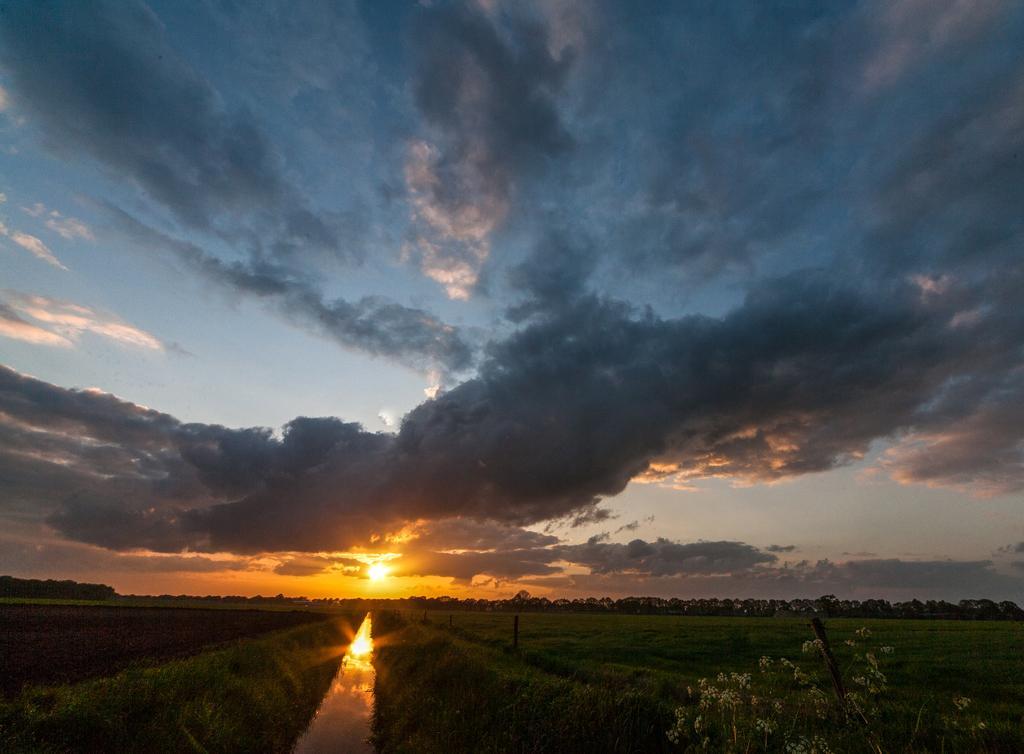Please provide a concise description of this image. In this image we can see an agricultural farm with grass and water on the surface, at the top of the image the sun is setting and there are clouds in the sky. 